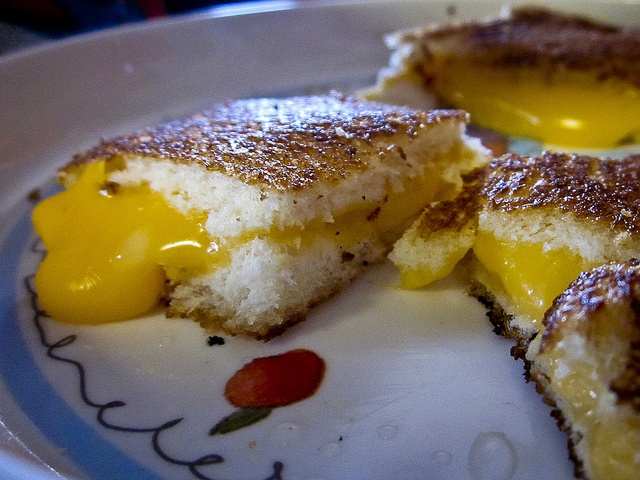Describe the objects in this image and their specific colors. I can see sandwich in black, olive, and lightgray tones, sandwich in black, olive, maroon, and tan tones, and sandwich in black, maroon, and olive tones in this image. 